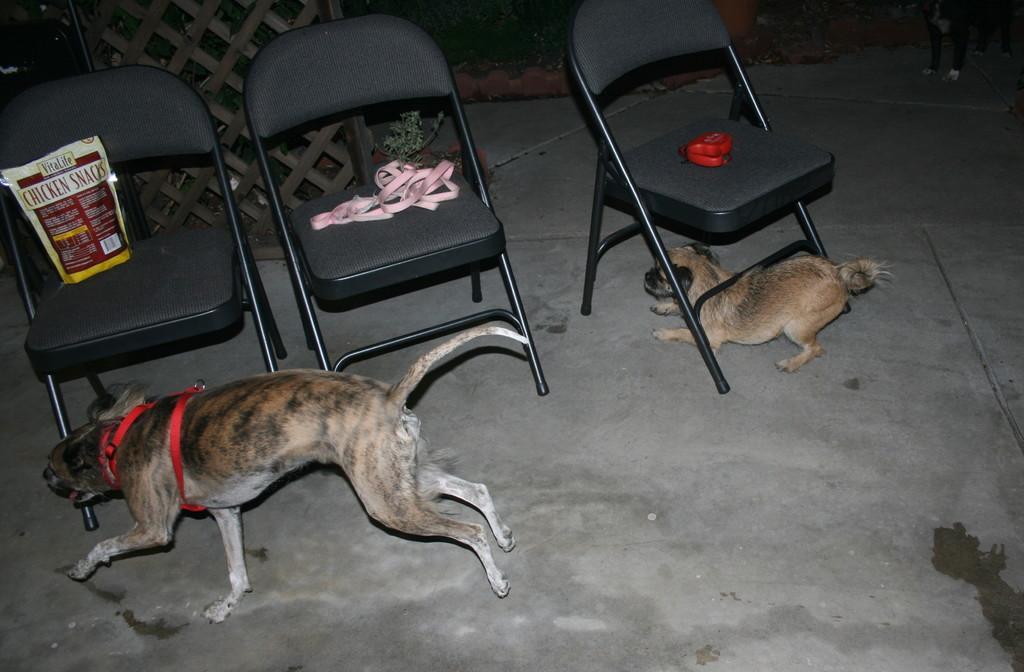Can you describe this image briefly? In this image there are two dogs which are under the chair and at the top of the chairs there was a leash and a food item and a object. 